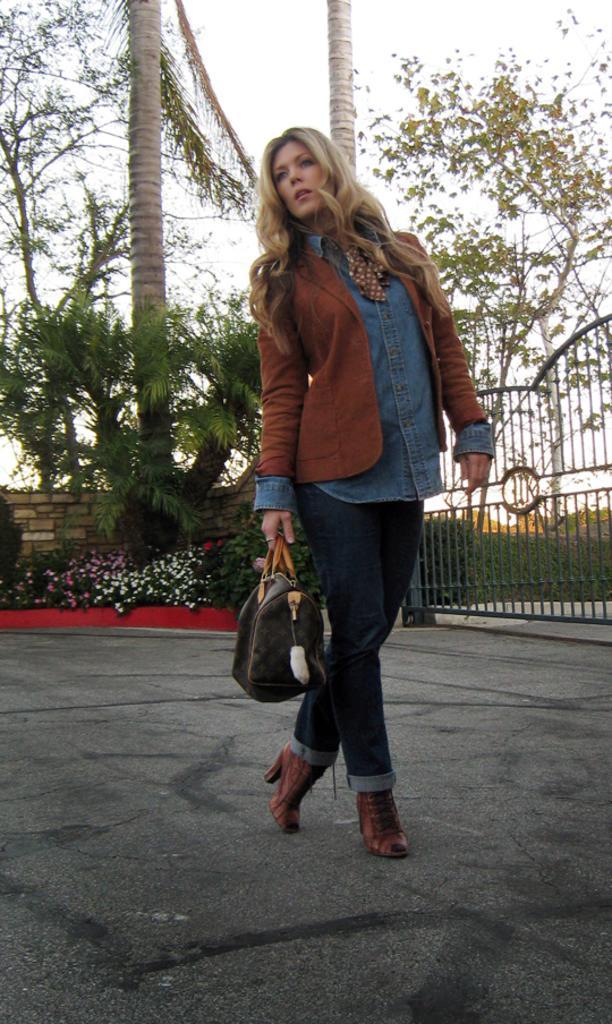Could you give a brief overview of what you see in this image? In the center we can see one woman standing and holding bag. And back there is a trees,sky,plant,flowers and gate. 